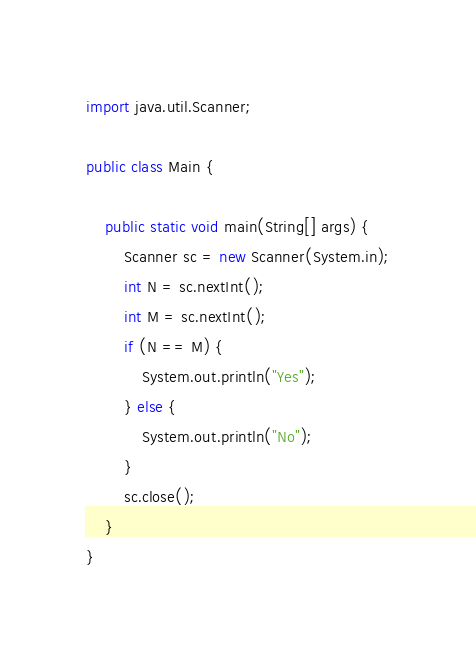<code> <loc_0><loc_0><loc_500><loc_500><_Java_>import java.util.Scanner;

public class Main {

	public static void main(String[] args) {
		Scanner sc = new Scanner(System.in);
		int N = sc.nextInt();
		int M = sc.nextInt();
		if (N == M) {
			System.out.println("Yes");
		} else {
			System.out.println("No");
		}
		sc.close();
	}
}</code> 